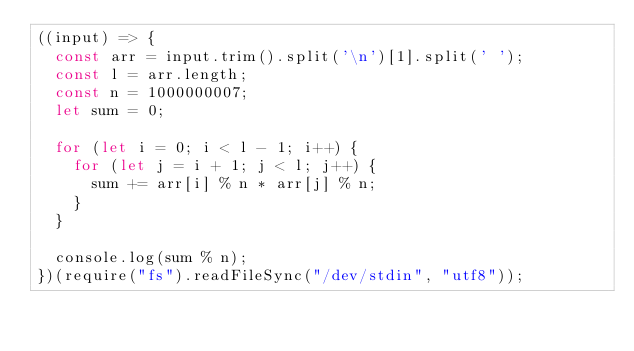Convert code to text. <code><loc_0><loc_0><loc_500><loc_500><_JavaScript_>((input) => {
  const arr = input.trim().split('\n')[1].split(' ');
  const l = arr.length;
  const n = 1000000007;
  let sum = 0;

  for (let i = 0; i < l - 1; i++) {
    for (let j = i + 1; j < l; j++) {
      sum += arr[i] % n * arr[j] % n;
    }
  }

  console.log(sum % n);
})(require("fs").readFileSync("/dev/stdin", "utf8"));</code> 